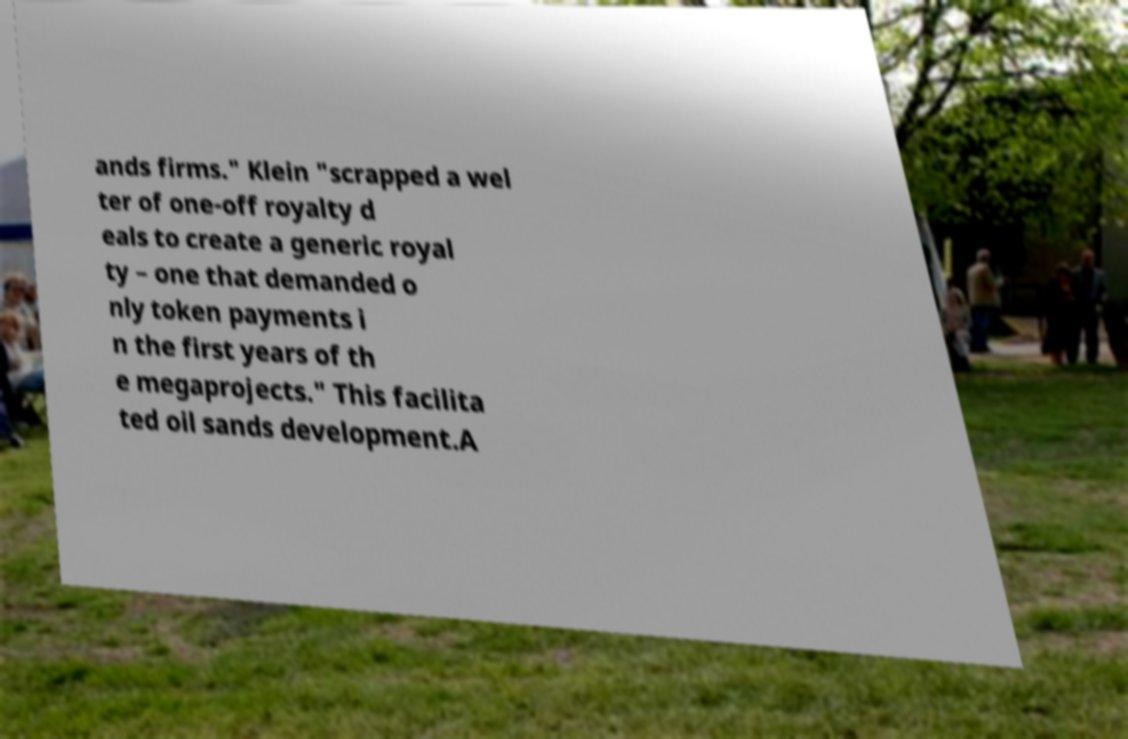Could you assist in decoding the text presented in this image and type it out clearly? ands firms." Klein "scrapped a wel ter of one-off royalty d eals to create a generic royal ty – one that demanded o nly token payments i n the first years of th e megaprojects." This facilita ted oil sands development.A 